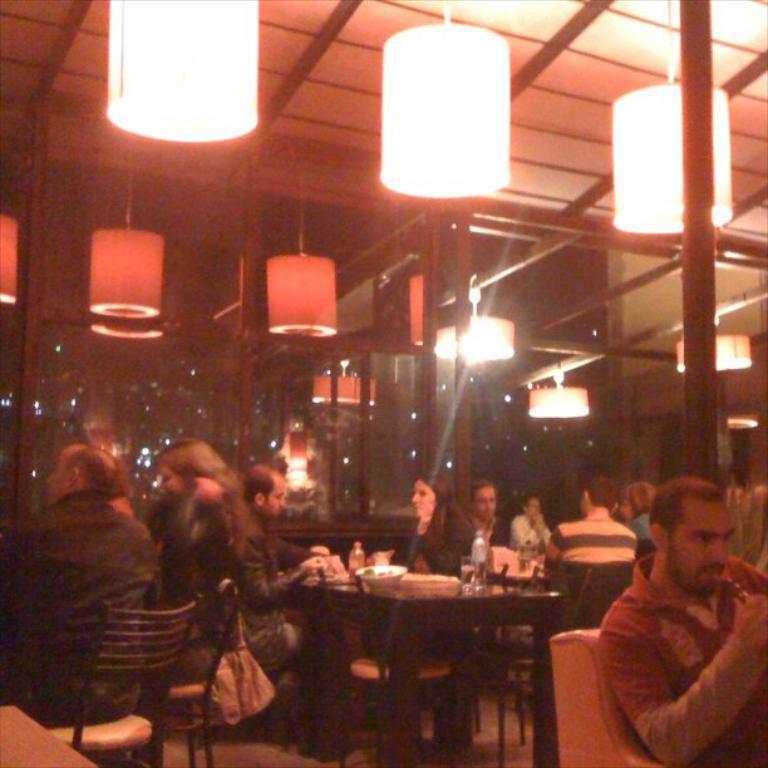How would you summarize this image in a sentence or two? In this picture of a group of people sitting and having their meal they have a table in front of them with some water bottles, glasses, plates and there are ceiling lights attached 